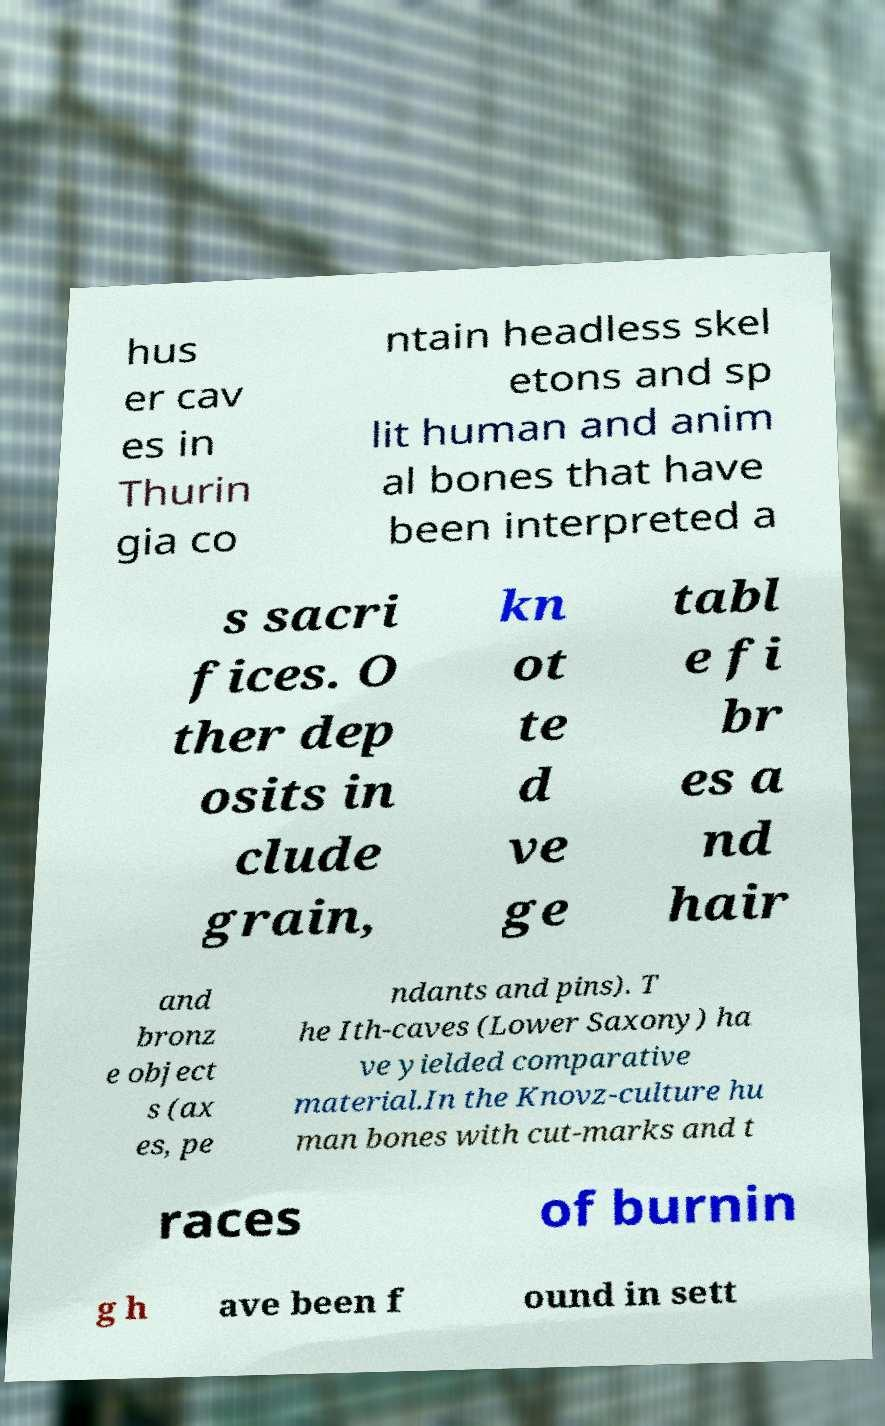There's text embedded in this image that I need extracted. Can you transcribe it verbatim? hus er cav es in Thurin gia co ntain headless skel etons and sp lit human and anim al bones that have been interpreted a s sacri fices. O ther dep osits in clude grain, kn ot te d ve ge tabl e fi br es a nd hair and bronz e object s (ax es, pe ndants and pins). T he Ith-caves (Lower Saxony) ha ve yielded comparative material.In the Knovz-culture hu man bones with cut-marks and t races of burnin g h ave been f ound in sett 